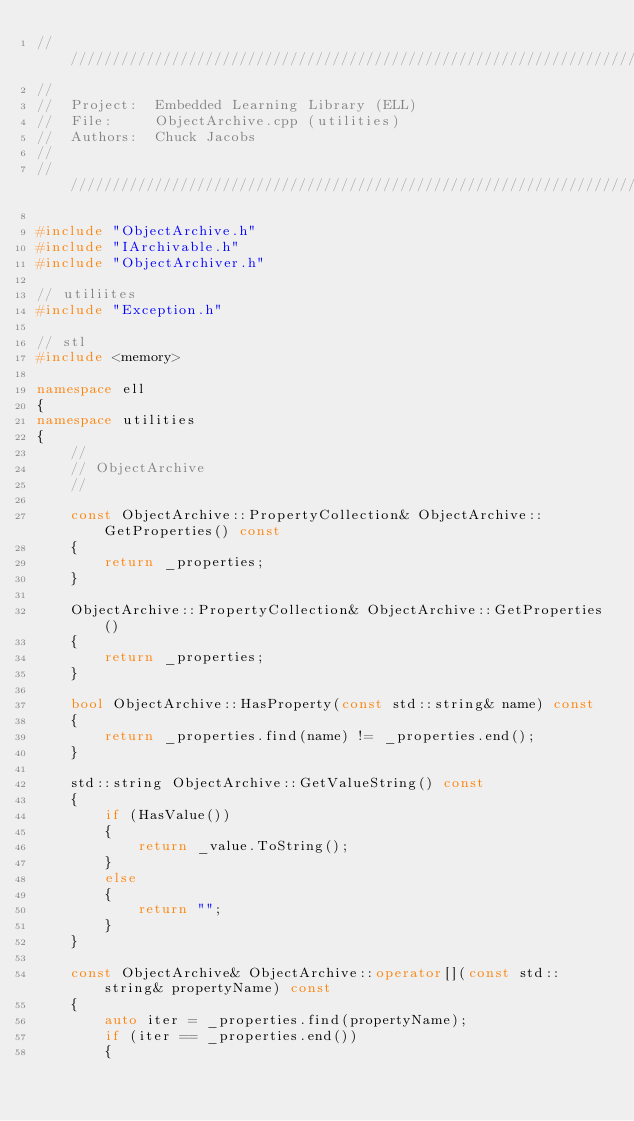Convert code to text. <code><loc_0><loc_0><loc_500><loc_500><_C++_>////////////////////////////////////////////////////////////////////////////////////////////////////
//
//  Project:  Embedded Learning Library (ELL)
//  File:     ObjectArchive.cpp (utilities)
//  Authors:  Chuck Jacobs
//
////////////////////////////////////////////////////////////////////////////////////////////////////

#include "ObjectArchive.h"
#include "IArchivable.h"
#include "ObjectArchiver.h"

// utiliites
#include "Exception.h"

// stl
#include <memory>

namespace ell
{
namespace utilities
{
    //
    // ObjectArchive
    //

    const ObjectArchive::PropertyCollection& ObjectArchive::GetProperties() const
    {
        return _properties;
    }

    ObjectArchive::PropertyCollection& ObjectArchive::GetProperties()
    {
        return _properties;
    }

    bool ObjectArchive::HasProperty(const std::string& name) const
    {
        return _properties.find(name) != _properties.end();
    }

    std::string ObjectArchive::GetValueString() const
    {
        if (HasValue())
        {
            return _value.ToString();
        }
        else
        {
            return "";
        }
    }

    const ObjectArchive& ObjectArchive::operator[](const std::string& propertyName) const
    {
        auto iter = _properties.find(propertyName);
        if (iter == _properties.end())
        {</code> 